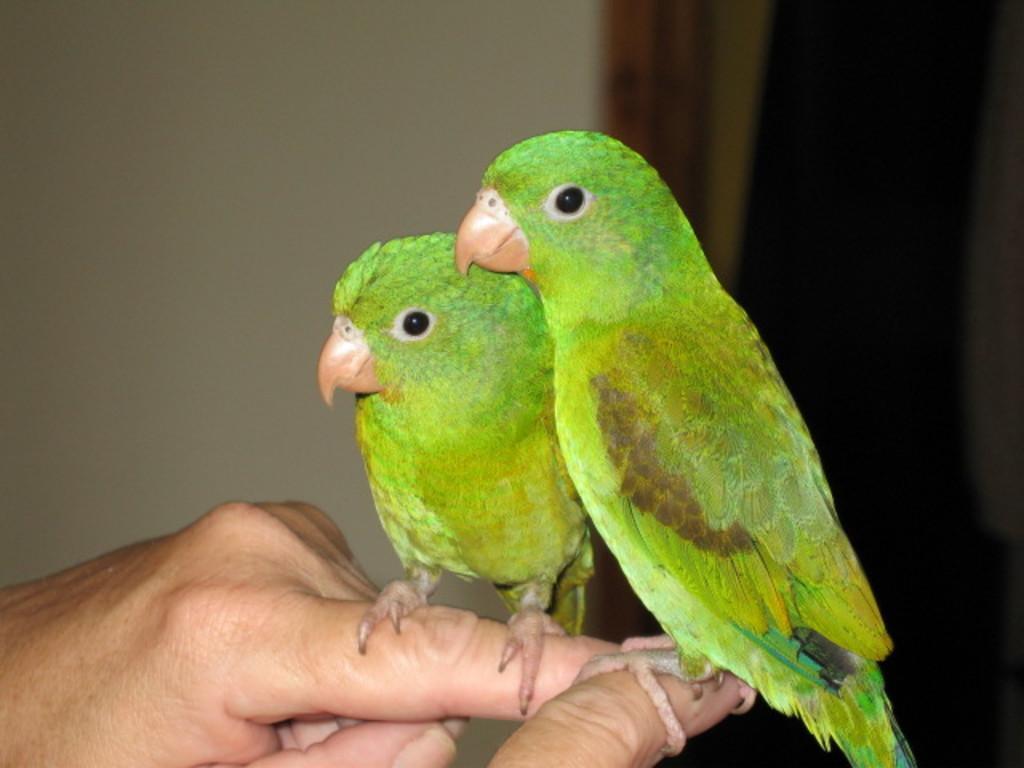Please provide a concise description of this image. In this picture there are two parrots on persons on fingers. The background is blurred. In the background there are curtain and wall. 